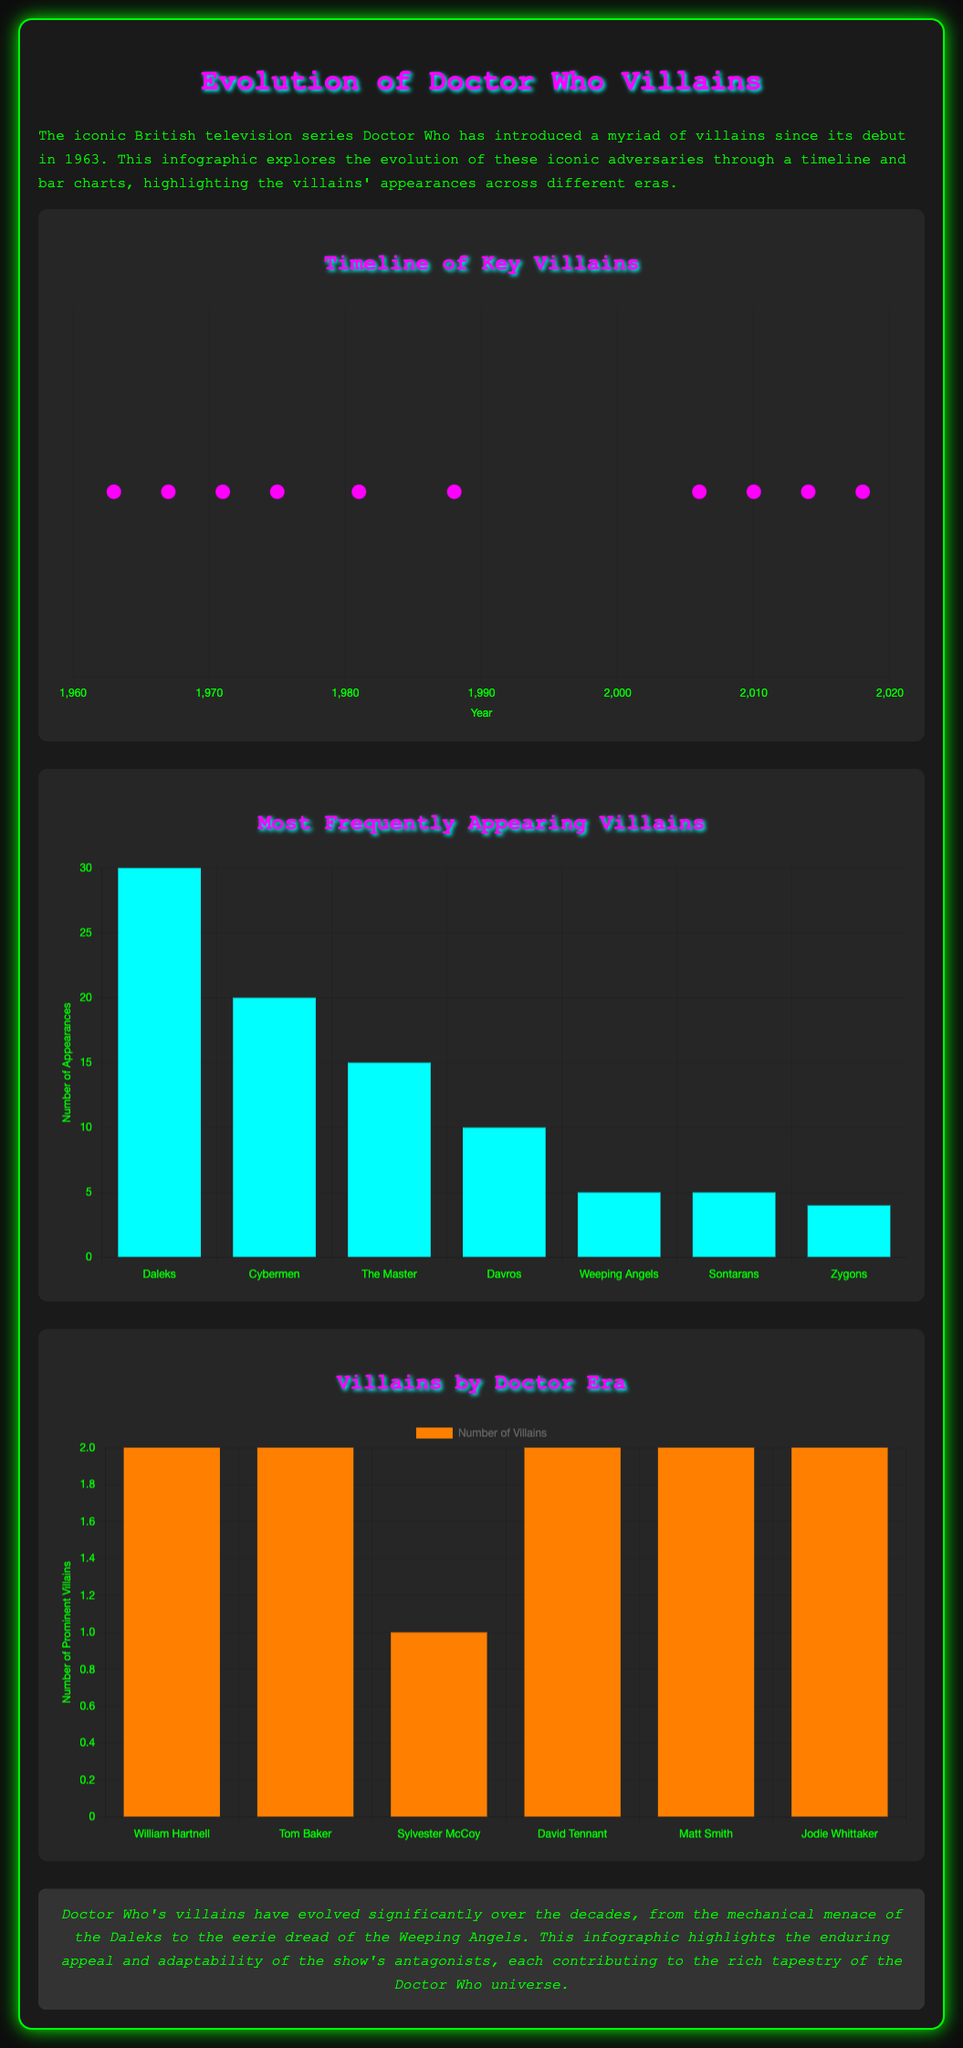what year did the Daleks first appear? The timeline chart indicates that the Daleks made their first appearance in the year 1963.
Answer: 1963 who is the villain associated with the year 2014? The timeline chart shows that Missy is the villain associated with the year 2014.
Answer: Missy which villain has the highest number of appearances? According to the villain frequency chart, the Daleks have the highest number of appearances at 30.
Answer: Daleks how many prominent villains were there during David Tennant's era? The doctor era chart reveals that there were 2 prominent villains during David Tennant's era.
Answer: 2 which Doctor had the same number of villains as Jodie Whittaker? The chart indicates that William Hartnell had the same number of villains (2) as Jodie Whittaker.
Answer: William Hartnell what is the total number of villain appearances shown in the villain chart? The total number of appearances can be calculated as the sum of appearances for each villain: 30 + 20 + 15 + 10 + 5 + 5 + 4 = 89.
Answer: 89 how many years did the Master appear in the show according to the timeline? The Master appeared in several years, with notable years being 1971 and also later in David Tennant's era, counting at least 2 distinct appearances across different decades.
Answer: 2 how many villains appeared during Tom Baker's era? The doctor era chart indicates that there were 2 villains during Tom Baker's era.
Answer: 2 which villain was introduced in 1988? The timeline shows that The Kandyman was introduced in 1988.
Answer: The Kandyman 